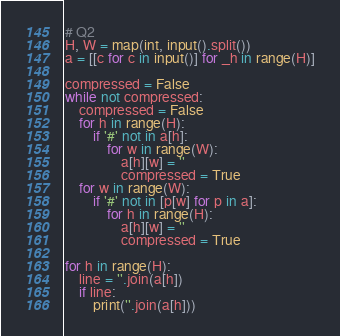<code> <loc_0><loc_0><loc_500><loc_500><_Python_># Q2
H, W = map(int, input().split())
a = [[c for c in input()] for _h in range(H)]

compressed = False
while not compressed:
    compressed = False
    for h in range(H):
        if '#' not in a[h]:
            for w in range(W):
                a[h][w] = ''
                compressed = True
    for w in range(W):
        if '#' not in [p[w] for p in a]:
            for h in range(H):
                a[h][w] = ''
                compressed = True

for h in range(H):
    line = ''.join(a[h])
    if line:
        print(''.join(a[h]))</code> 